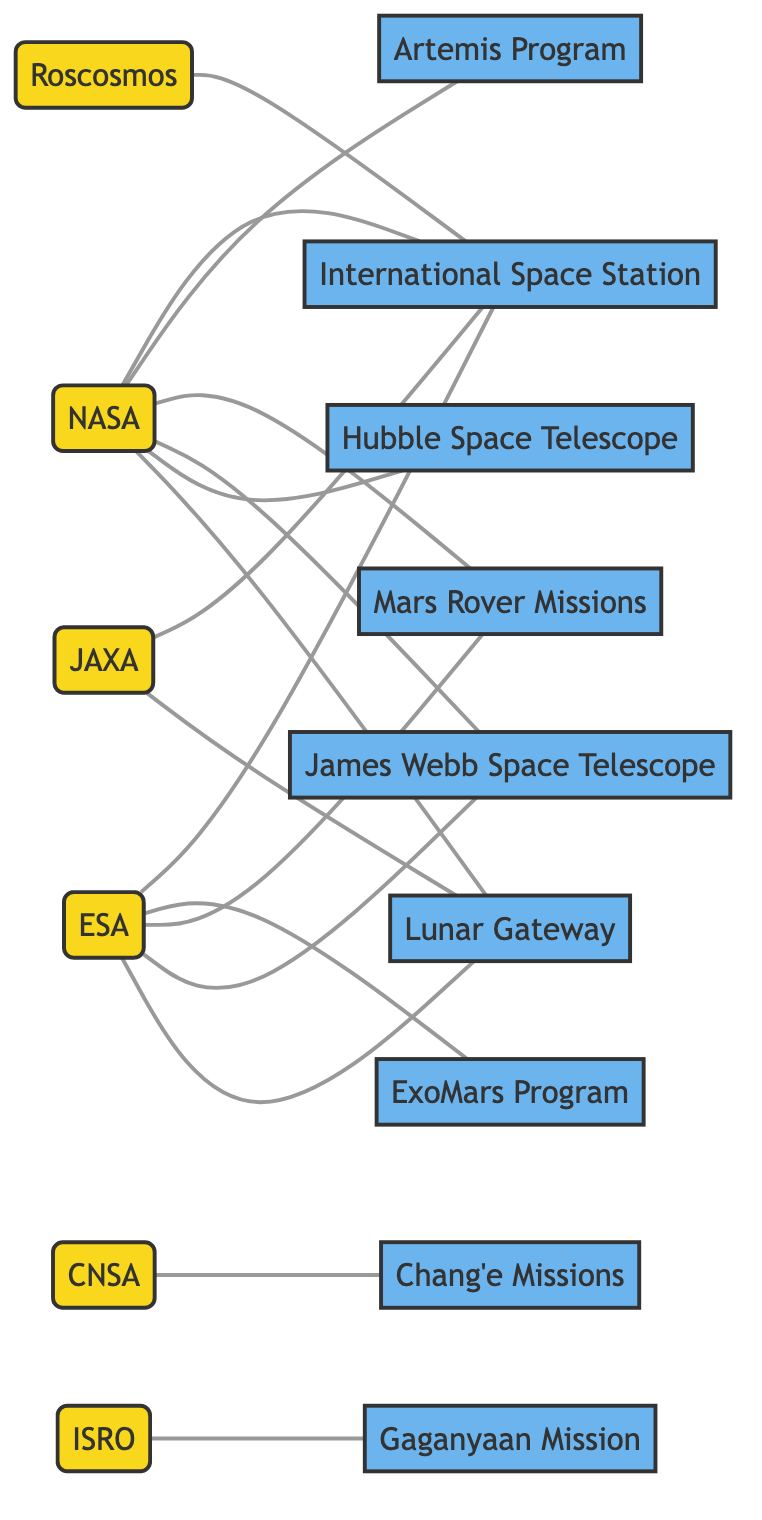What organizations are connected to the International Space Station? By examining the edges linked to the node representing the International Space Station, we can identify the organizations directly connected to it. The edges indicate connections to NASA, ESA, Roscosmos, and JAXA.
Answer: NASA, ESA, Roscosmos, JAXA How many missions are affiliated with NASA? Counting the number of edges that have NASA as the starting point reveals how many missions it is connected to. The count is 7 (International Space Station, Artemis Program, Mars Rover Missions, James Webb Space Telescope, Hubble Space Telescope, Lunar Gateway).
Answer: 7 Which agency is involved with the Gaganyaan Mission? Looking at the edge specifically linked to Gaganyaan Mission, we see that ISRO is the agency connected to it, as it appears as the 'from' node in the relevant edge.
Answer: ISRO Which organizations collaborate on the Lunar Gateway? To find this, we examine the edges leading to the Lunar Gateway node. The edges show that NASA, ESA, and JAXA are all linked to this mission, indicating collaboration among them.
Answer: NASA, ESA, JAXA What is the total number of nodes in this graph? The total number of nodes is determined by counting each unique organization and mission in the graph. There are 15 distinct nodes when combined.
Answer: 15 How many agencies are connected to the Mars Rover Missions? By checking the connections associated with the Mars Rover Missions node, we find that it is linked to both NASA and ESA, totaling to two agencies.
Answer: 2 Which mission is associated with the CNSA? Since CNSA is only connected to one mission, we can identify this by reviewing its connection, which is the Chang'e Missions.
Answer: Chang'e Missions Which agency has the most connections in the graph? To determine which agency has the most connections, we can count each edge originating from each agency node. NASA has connections to 7 different missions, making it the agency with the most connections.
Answer: NASA How many missions are represented in the graph? By counting the unique missions defined as nodes in the graph, we find there are 8 distinct missions, which include the International Space Station and various exploratory programs.
Answer: 8 